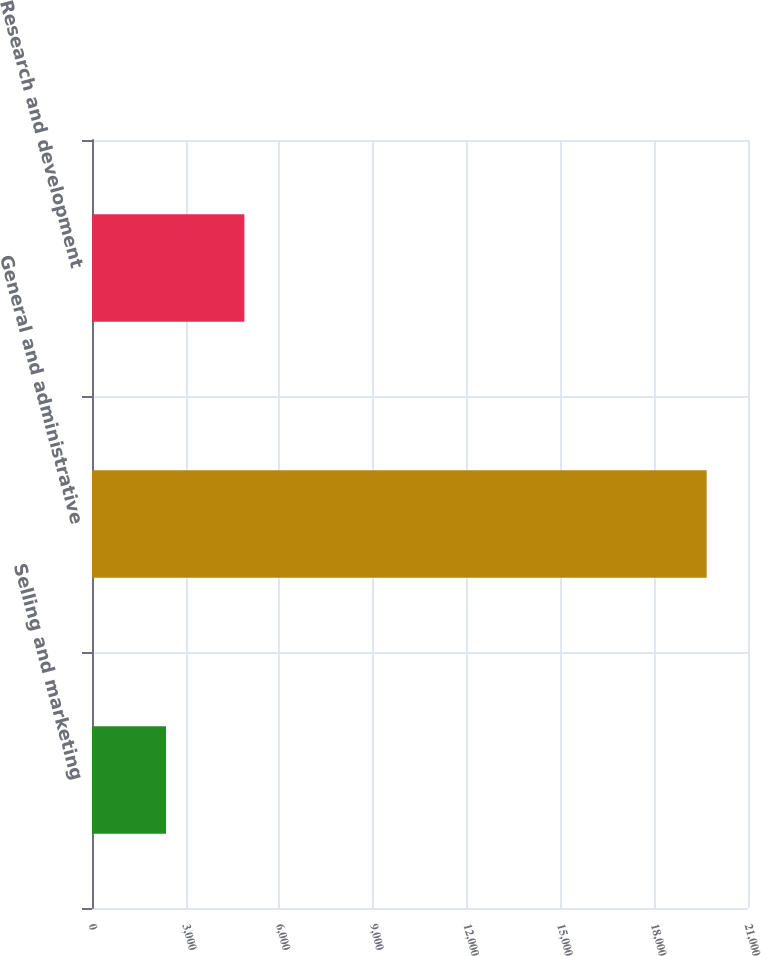Convert chart. <chart><loc_0><loc_0><loc_500><loc_500><bar_chart><fcel>Selling and marketing<fcel>General and administrative<fcel>Research and development<nl><fcel>2370<fcel>19678<fcel>4878<nl></chart> 